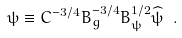<formula> <loc_0><loc_0><loc_500><loc_500>\psi \equiv C ^ { - 3 / 4 } B _ { g } ^ { - 3 / 4 } B _ { \psi } ^ { 1 / 2 } \widehat { \psi } \ .</formula> 